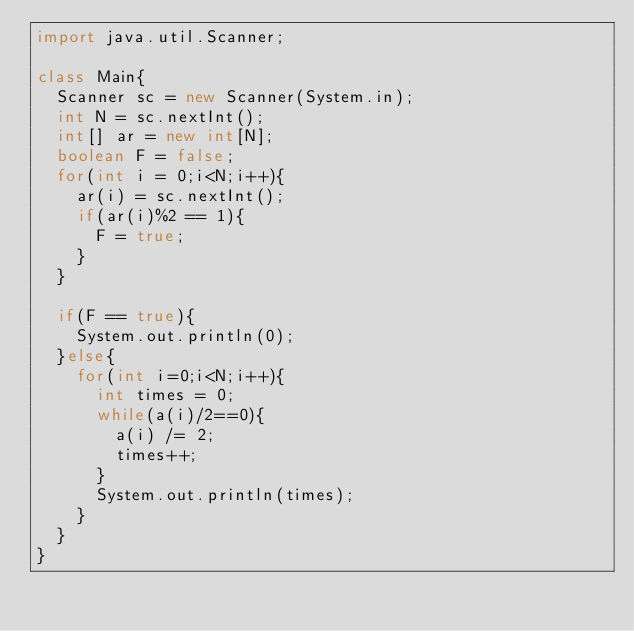Convert code to text. <code><loc_0><loc_0><loc_500><loc_500><_Java_>import java.util.Scanner;
 
class Main{
  Scanner sc = new Scanner(System.in);
  int N = sc.nextInt();
  int[] ar = new int[N];
  boolean F = false;
  for(int i = 0;i<N;i++){
    ar(i) = sc.nextInt();
    if(ar(i)%2 == 1){
      F = true;
    }
  }
  
  if(F == true){
    System.out.println(0);
  }else{
    for(int i=0;i<N;i++){
      int times = 0;
      while(a(i)/2==0){
        a(i) /= 2;
        times++;
      }
      System.out.println(times);
    }
  }
}  </code> 